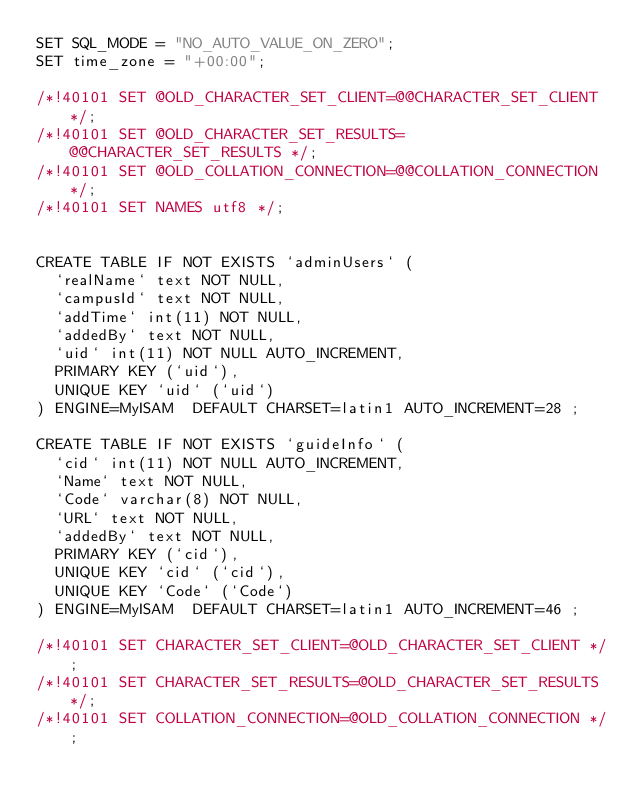Convert code to text. <code><loc_0><loc_0><loc_500><loc_500><_SQL_>SET SQL_MODE = "NO_AUTO_VALUE_ON_ZERO";
SET time_zone = "+00:00";

/*!40101 SET @OLD_CHARACTER_SET_CLIENT=@@CHARACTER_SET_CLIENT */;
/*!40101 SET @OLD_CHARACTER_SET_RESULTS=@@CHARACTER_SET_RESULTS */;
/*!40101 SET @OLD_COLLATION_CONNECTION=@@COLLATION_CONNECTION */;
/*!40101 SET NAMES utf8 */;


CREATE TABLE IF NOT EXISTS `adminUsers` (
  `realName` text NOT NULL,
  `campusId` text NOT NULL,
  `addTime` int(11) NOT NULL,
  `addedBy` text NOT NULL,
  `uid` int(11) NOT NULL AUTO_INCREMENT,
  PRIMARY KEY (`uid`),
  UNIQUE KEY `uid` (`uid`)
) ENGINE=MyISAM  DEFAULT CHARSET=latin1 AUTO_INCREMENT=28 ;

CREATE TABLE IF NOT EXISTS `guideInfo` (
  `cid` int(11) NOT NULL AUTO_INCREMENT,
  `Name` text NOT NULL,
  `Code` varchar(8) NOT NULL,
  `URL` text NOT NULL,
  `addedBy` text NOT NULL,
  PRIMARY KEY (`cid`),
  UNIQUE KEY `cid` (`cid`),
  UNIQUE KEY `Code` (`Code`)
) ENGINE=MyISAM  DEFAULT CHARSET=latin1 AUTO_INCREMENT=46 ;

/*!40101 SET CHARACTER_SET_CLIENT=@OLD_CHARACTER_SET_CLIENT */;
/*!40101 SET CHARACTER_SET_RESULTS=@OLD_CHARACTER_SET_RESULTS */;
/*!40101 SET COLLATION_CONNECTION=@OLD_COLLATION_CONNECTION */;
</code> 